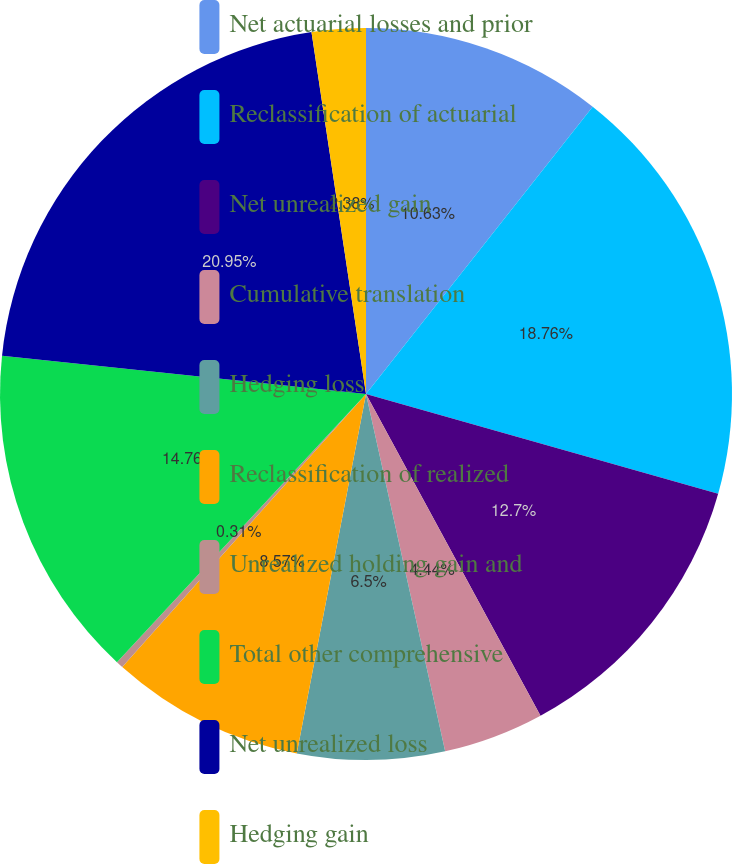Convert chart to OTSL. <chart><loc_0><loc_0><loc_500><loc_500><pie_chart><fcel>Net actuarial losses and prior<fcel>Reclassification of actuarial<fcel>Net unrealized gain<fcel>Cumulative translation<fcel>Hedging loss<fcel>Reclassification of realized<fcel>Unrealized holding gain and<fcel>Total other comprehensive<fcel>Net unrealized loss<fcel>Hedging gain<nl><fcel>10.63%<fcel>18.76%<fcel>12.7%<fcel>4.44%<fcel>6.5%<fcel>8.57%<fcel>0.31%<fcel>14.76%<fcel>20.95%<fcel>2.38%<nl></chart> 